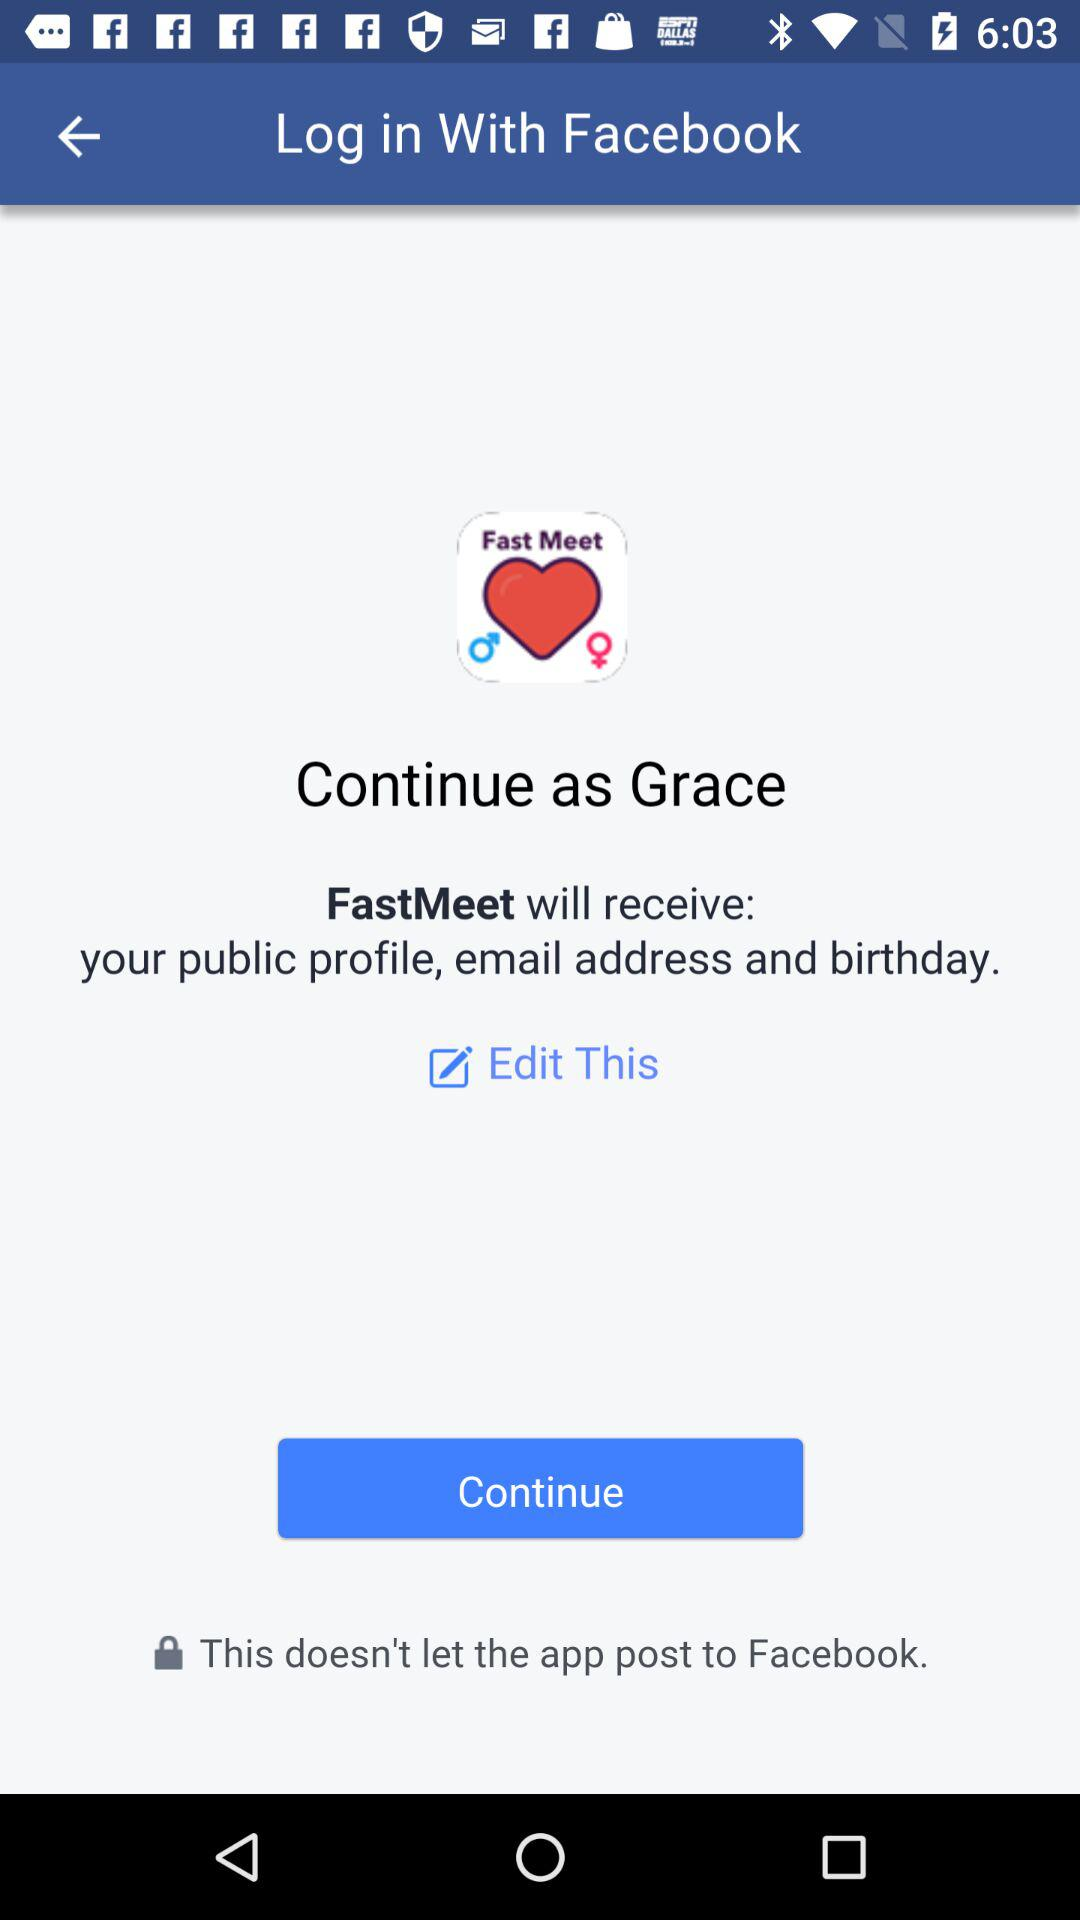What's the user name? The user name is Grace. 